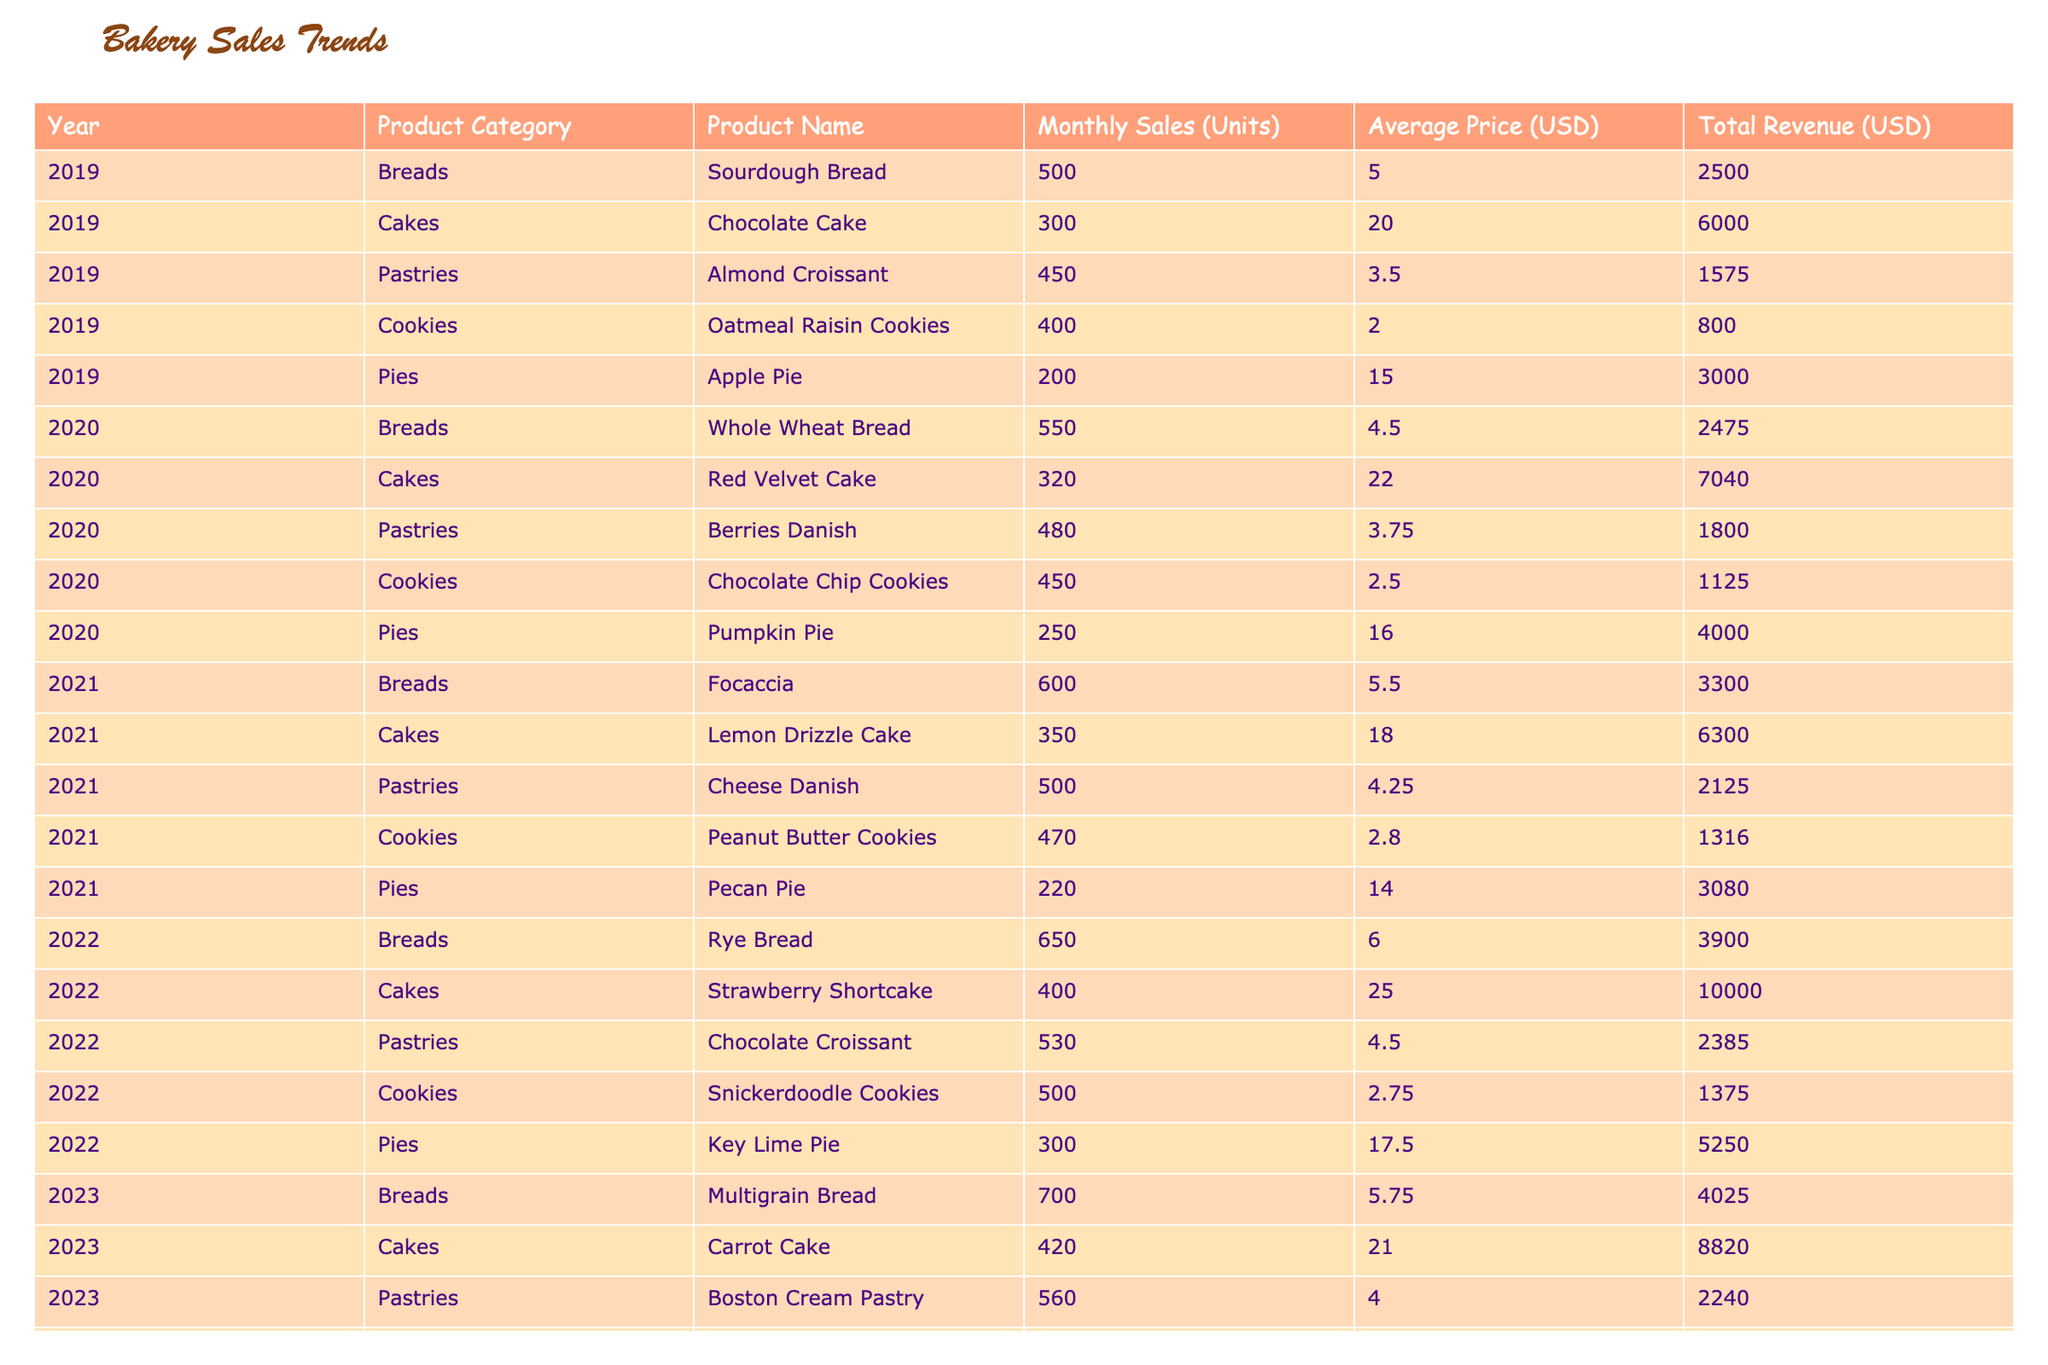What was the total revenue from Chocolate Cake in 2020? To find the total revenue from Chocolate Cake in 2020, we look at the 2020 row under the Cakes category. The total revenue for Chocolate Cake is $7040.
Answer: $7040 Which product category had the highest average price in 2022? In 2022, we compare the average prices across product categories: Breads ($6.00), Cakes ($25.00), Pastries ($4.50), Cookies ($2.75), and Pies ($17.50). The highest average price is from Cakes at $25.00.
Answer: Cakes How many more units of Rye Bread were sold than Lemon Drizzle Cake in 2021? In 2021, Rye Bread sold 650 units, and Lemon Drizzle Cake sold 350 units. The difference is 650 - 350 = 300 units.
Answer: 300 units Did the total revenue from Pastries increase or decrease from 2019 to 2023? We sum the total revenues for Pastries in the years: In 2019, it was $1575; in 2023, it was $2240. Comparing these two values, $2240 is greater than $1575, indicating an increase.
Answer: Increase What is the average monthly sales for Pies over the five years? To calculate the average monthly sales for Pies, we add the monthly sales across all years: 200 (2019) + 250 (2020) + 220 (2021) + 300 (2022) + 350 (2023) = 1320. We then divide by the number of years (5), giving an average of 1320 / 5 = 264.
Answer: 264 